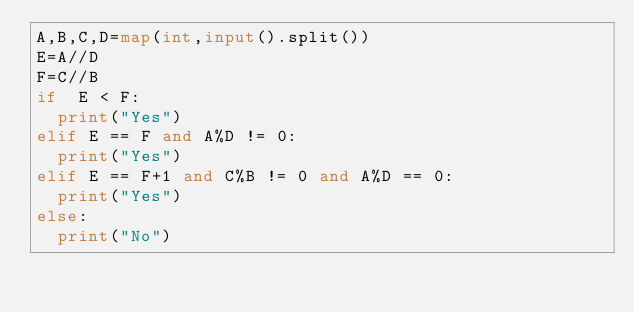Convert code to text. <code><loc_0><loc_0><loc_500><loc_500><_Python_>A,B,C,D=map(int,input().split())
E=A//D
F=C//B
if  E < F:
	print("Yes")
elif E == F and A%D != 0:
	print("Yes")
elif E == F+1 and C%B != 0 and A%D == 0:
	print("Yes")    
else:
	print("No")</code> 